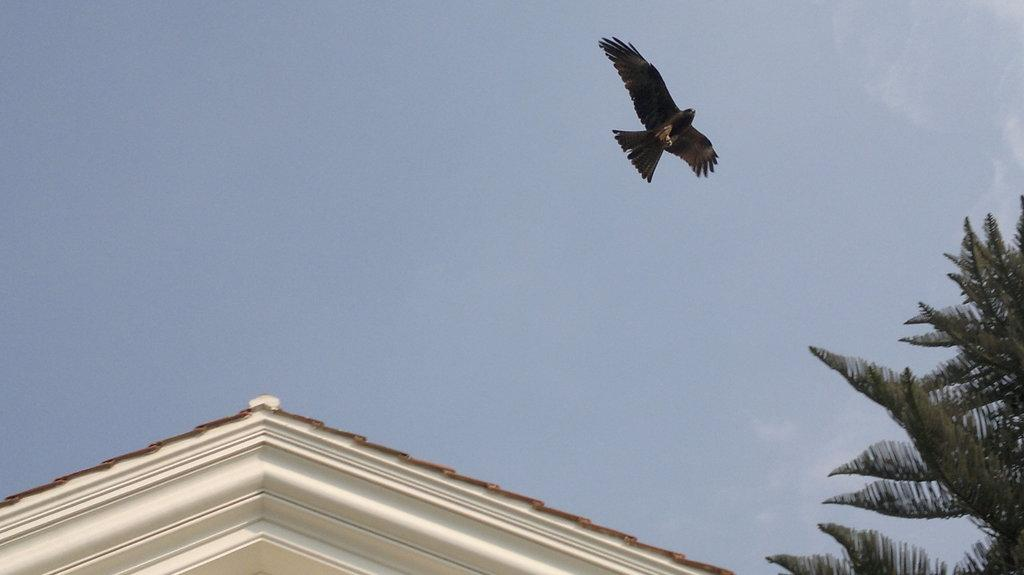What type of vegetation is on the right side of the image? There is a tree on the right side of the image. What structure can be seen in the image? There is a building in the image. What is the bird in the image doing? A bird is flying in the air in the image. What is visible at the top of the image? The sky is visible at the top of the image. What direction is the tree facing in the image? The direction the tree is facing cannot be determined from the image. Is there a seashore visible in the image? No, there is no seashore present in the image. 